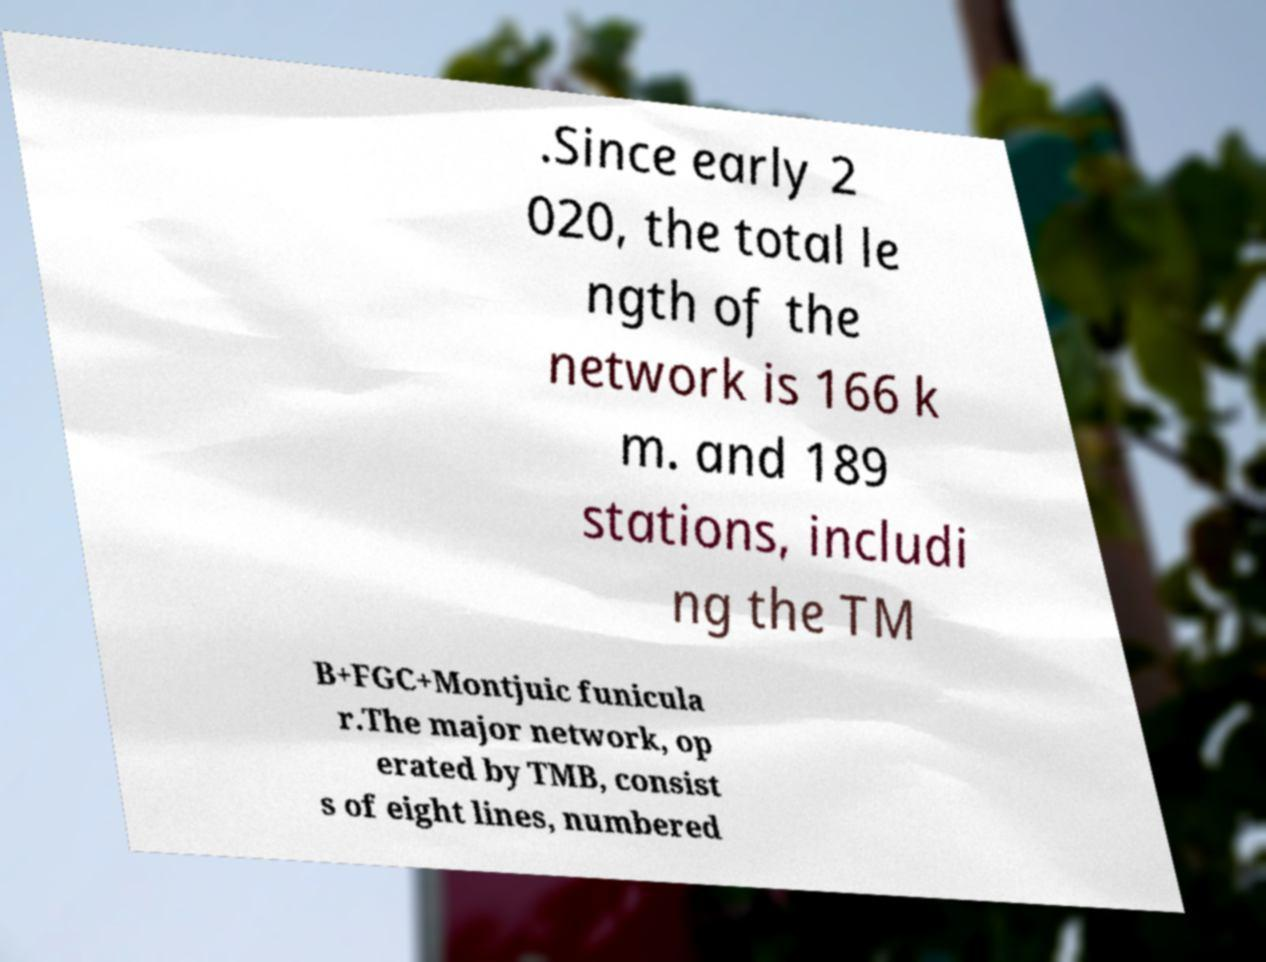Can you read and provide the text displayed in the image?This photo seems to have some interesting text. Can you extract and type it out for me? .Since early 2 020, the total le ngth of the network is 166 k m. and 189 stations, includi ng the TM B+FGC+Montjuic funicula r.The major network, op erated by TMB, consist s of eight lines, numbered 